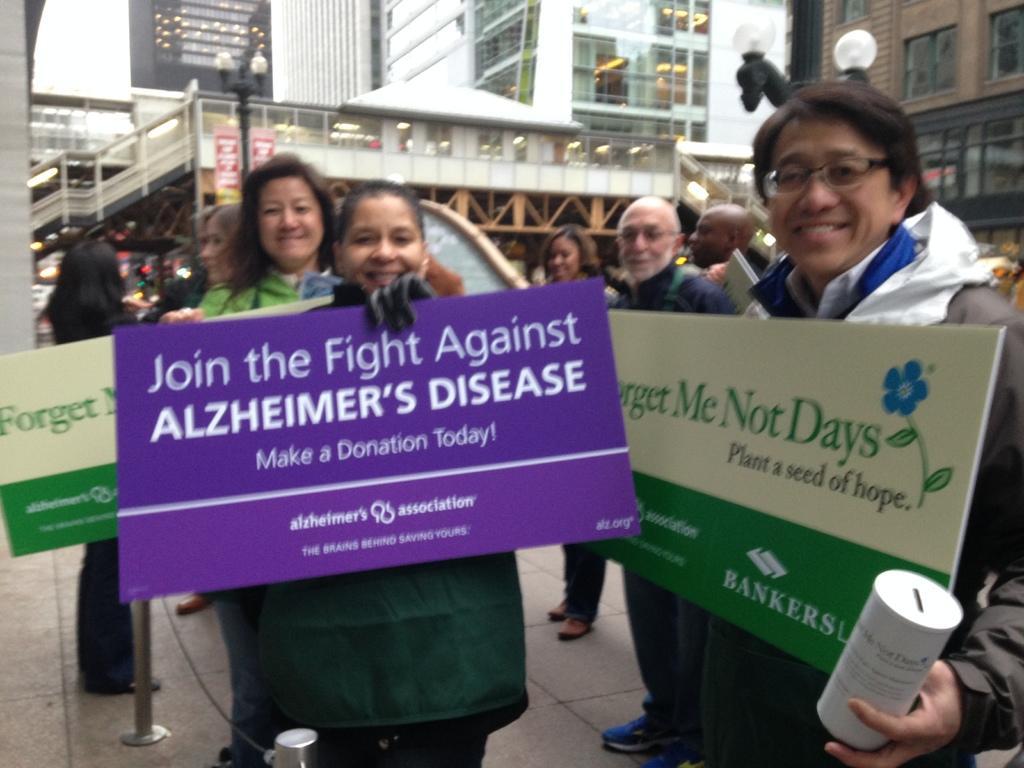In one or two sentences, can you explain what this image depicts? In this image we can see a few people standing and holding some board on their hands. In the background of the image there are few buildings. 